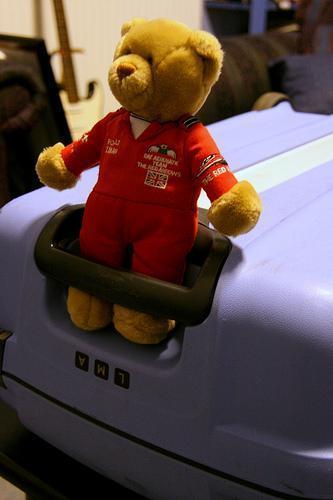How many bears are shown?
Give a very brief answer. 1. 